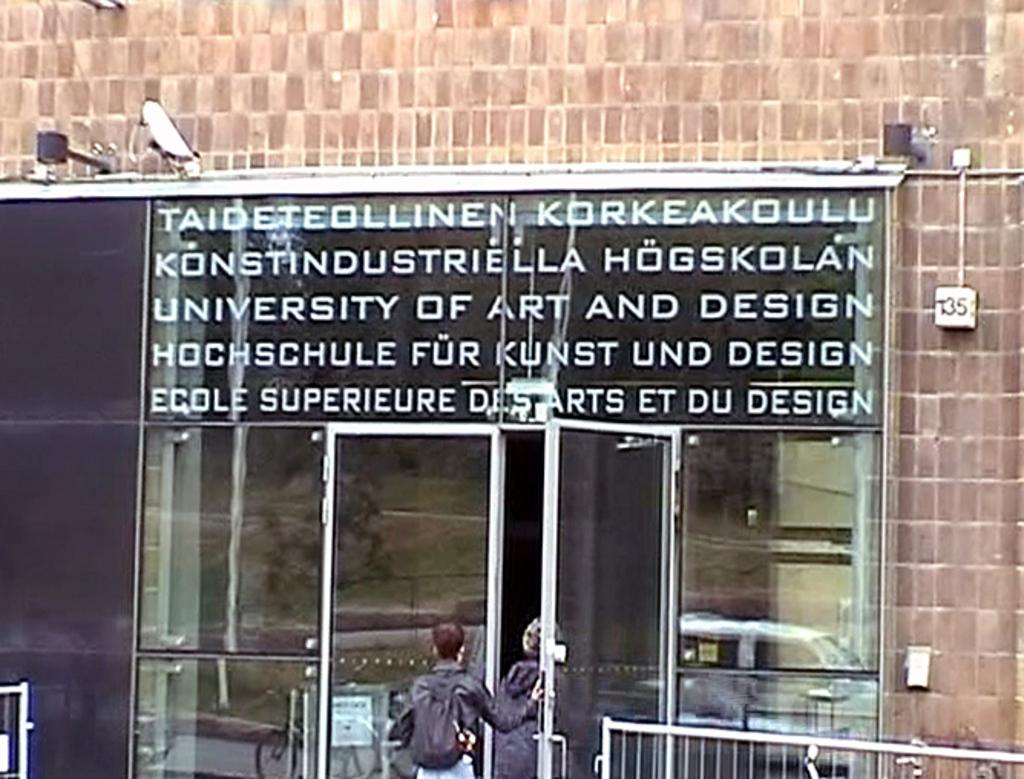How many people are in the image? There are two persons in the image. What is the main object in the image? There is a glass board in the image. What type of structure can be seen in the image? There is a fence in the image. Can you describe the door in the image? There is a door in the image. What objects are present in the image? There are glasses in the image. What does the glass board reflect? The glasses reflect a car, a bicycle, a board, and trees. What is the background of the image? There is a wall in the image. What type of cream can be seen on the chicken in the image? There is no chicken or cream present in the image. What type of border is visible in the image? There is no border visible in the image. 